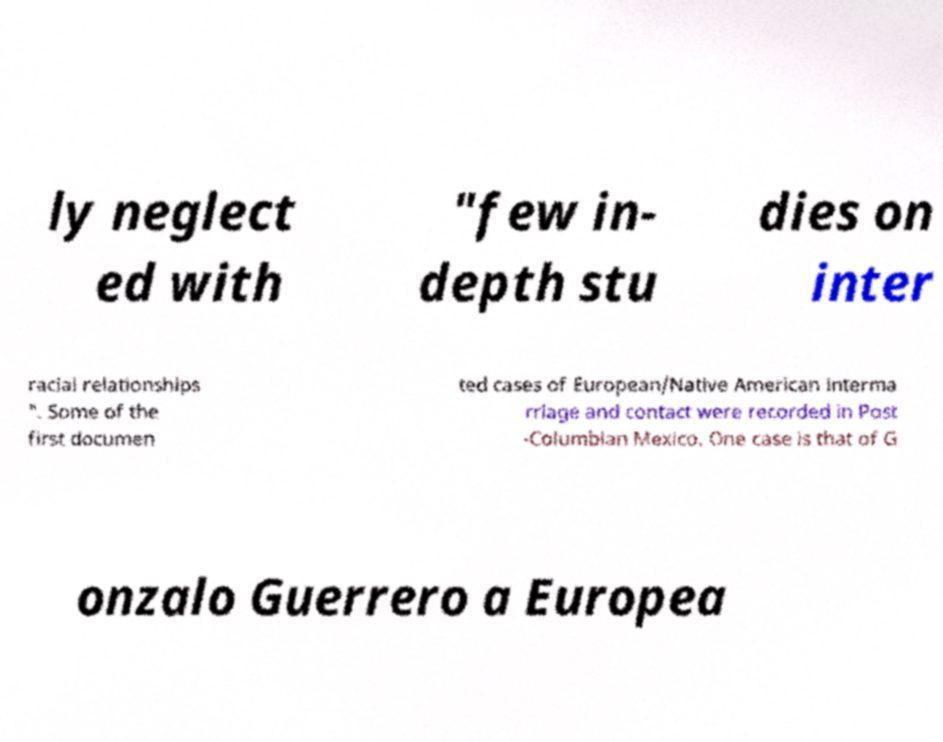I need the written content from this picture converted into text. Can you do that? ly neglect ed with "few in- depth stu dies on inter racial relationships ". Some of the first documen ted cases of European/Native American interma rriage and contact were recorded in Post -Columbian Mexico. One case is that of G onzalo Guerrero a Europea 